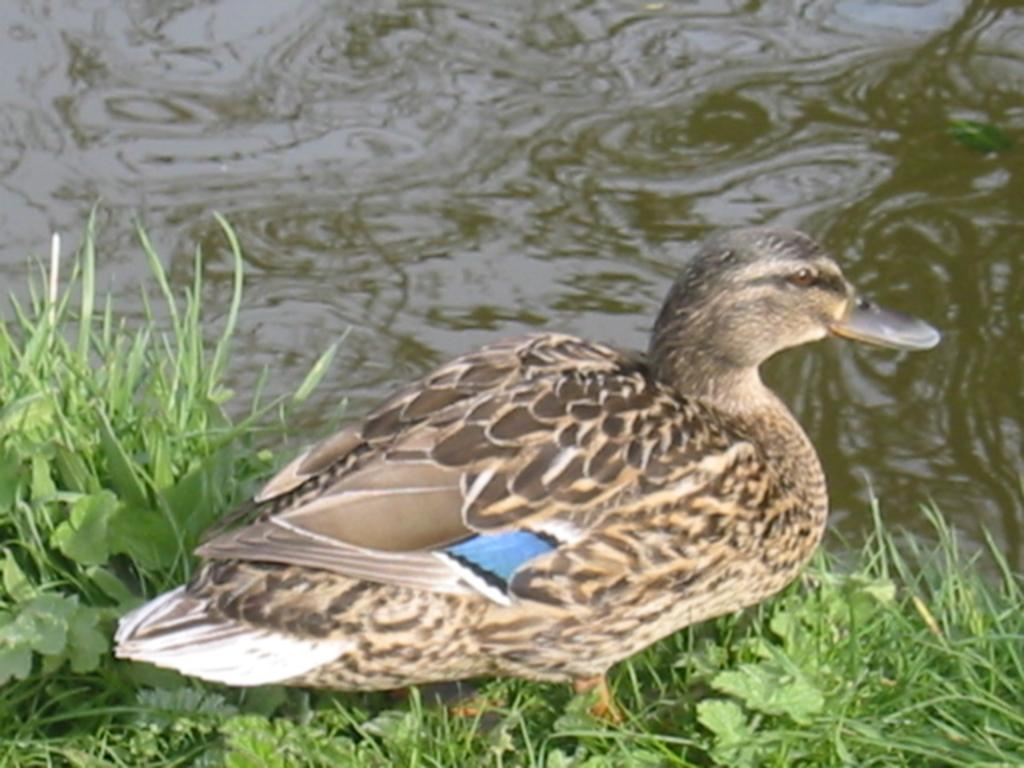What type of animal can be seen in the image? There is a bird in the image. What other living organisms are present in the image? There are plants in the image. What type of vegetation is visible in the image? There is grass in the image. What natural element can be seen in the image? There is water visible in the image. What type of seed is the bird planting in the image? There is no seed present in the image, nor is there any indication that the bird is planting anything. 